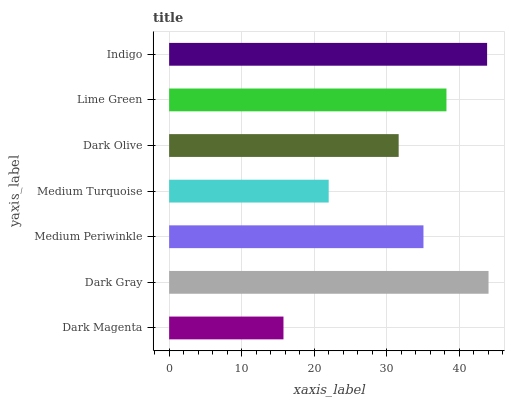Is Dark Magenta the minimum?
Answer yes or no. Yes. Is Dark Gray the maximum?
Answer yes or no. Yes. Is Medium Periwinkle the minimum?
Answer yes or no. No. Is Medium Periwinkle the maximum?
Answer yes or no. No. Is Dark Gray greater than Medium Periwinkle?
Answer yes or no. Yes. Is Medium Periwinkle less than Dark Gray?
Answer yes or no. Yes. Is Medium Periwinkle greater than Dark Gray?
Answer yes or no. No. Is Dark Gray less than Medium Periwinkle?
Answer yes or no. No. Is Medium Periwinkle the high median?
Answer yes or no. Yes. Is Medium Periwinkle the low median?
Answer yes or no. Yes. Is Medium Turquoise the high median?
Answer yes or no. No. Is Dark Olive the low median?
Answer yes or no. No. 